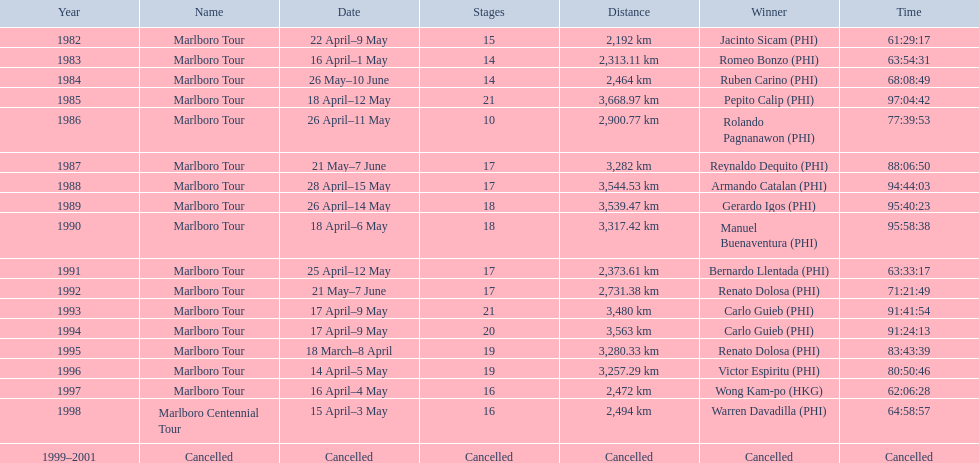In what year did warren davdilla (w.d.) make an appearance? 1998. Which tour was completed by w.d.? Marlboro Centennial Tour. What is the recorded time in the same row as w.d.? 64:58:57. 